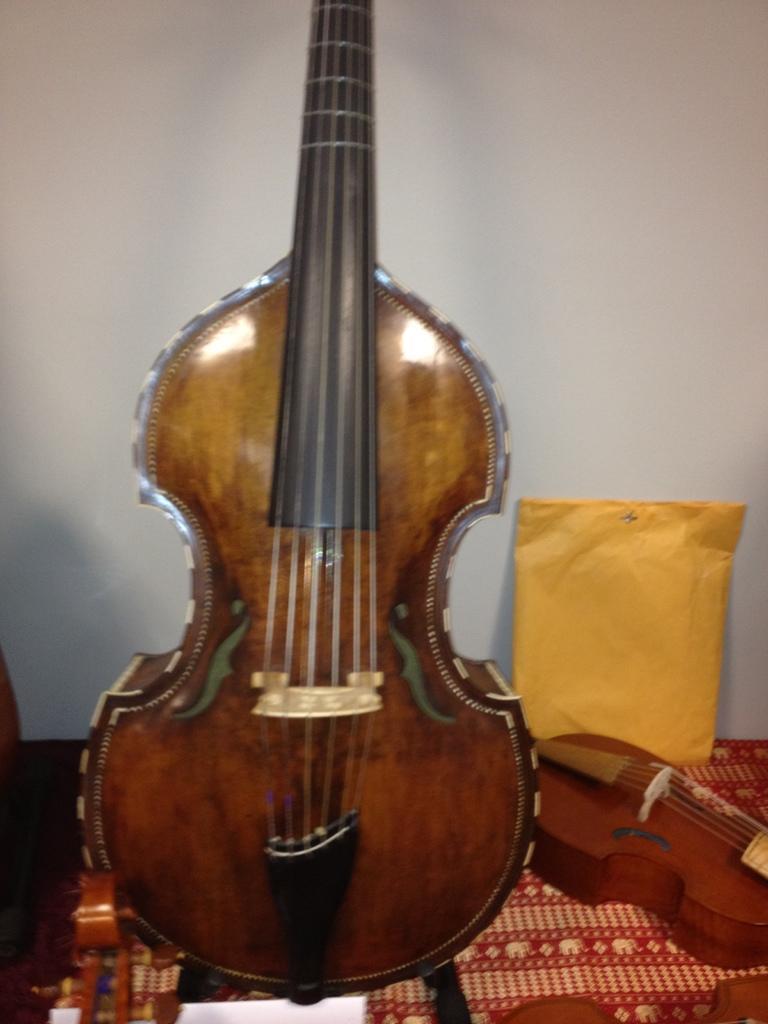Could you give a brief overview of what you see in this image? In this picture there is a guitar beside it there is a violin. Behind the violin there is a packet. these all things are on a table. In the background there is a white wall. 